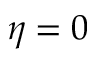<formula> <loc_0><loc_0><loc_500><loc_500>\eta = 0</formula> 